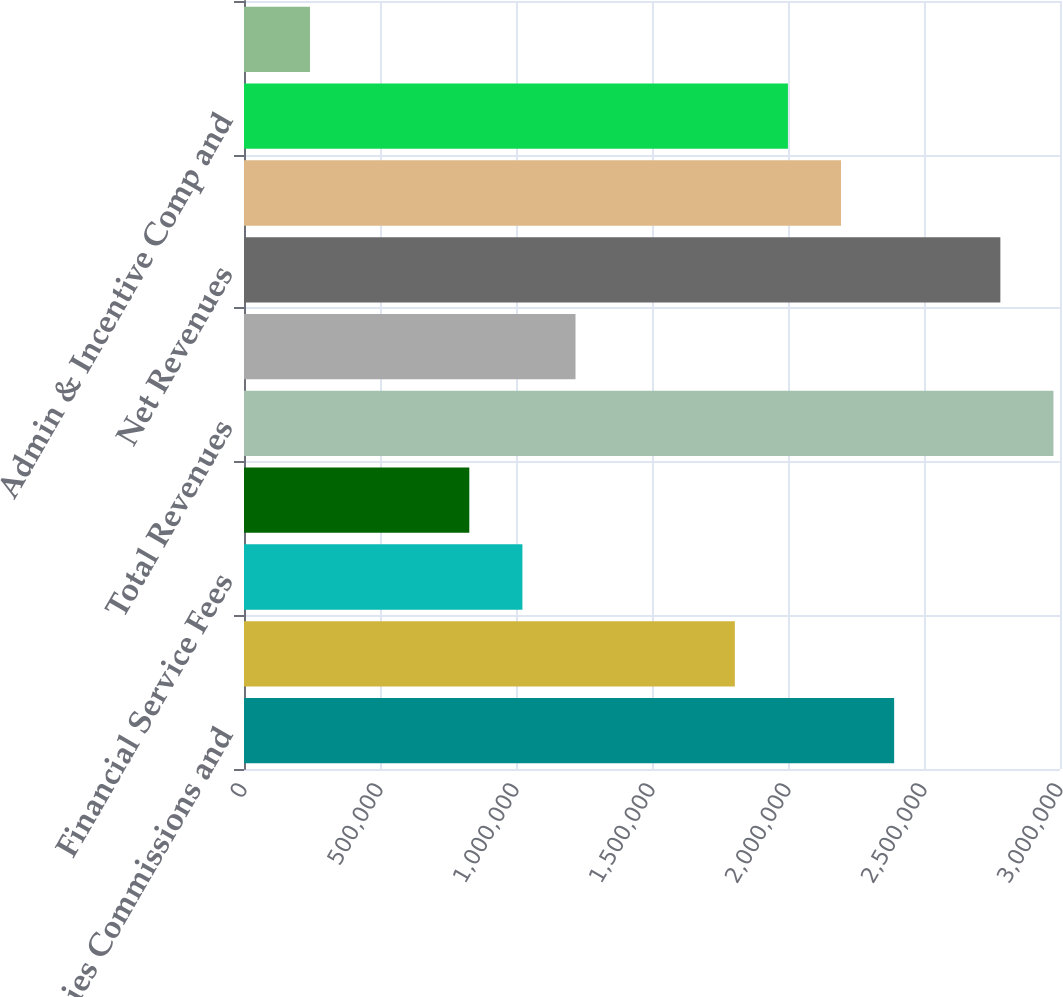Convert chart. <chart><loc_0><loc_0><loc_500><loc_500><bar_chart><fcel>Securities Commissions and<fcel>Interest<fcel>Financial Service Fees<fcel>Other<fcel>Total Revenues<fcel>Interest Expense<fcel>Net Revenues<fcel>Sales Commissions<fcel>Admin & Incentive Comp and<fcel>Communications and Information<nl><fcel>2.39026e+06<fcel>1.80453e+06<fcel>1.02357e+06<fcel>828331<fcel>2.97598e+06<fcel>1.21881e+06<fcel>2.78074e+06<fcel>2.19502e+06<fcel>1.99978e+06<fcel>242610<nl></chart> 